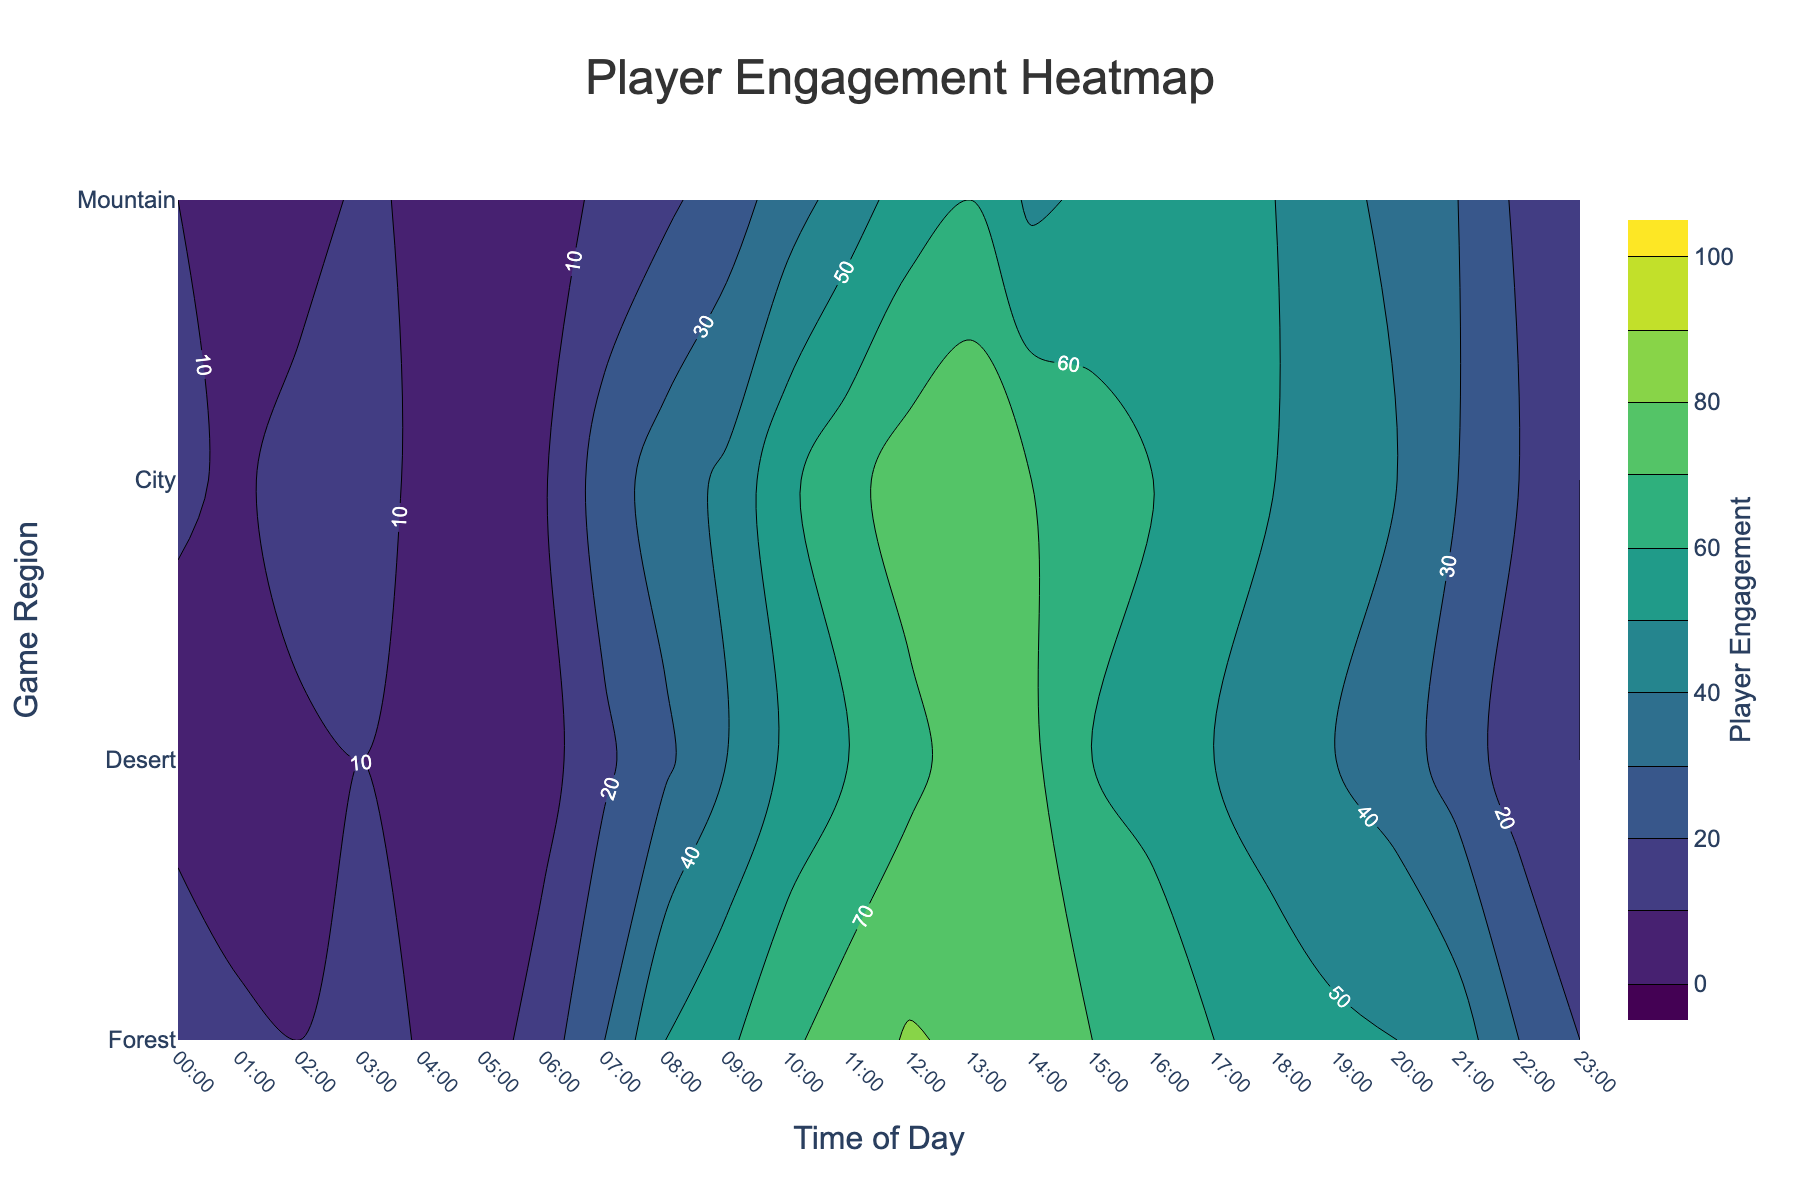What is the title of the figure? The title of the figure is displayed at the top and centered. It provides a brief description of the main theme of the plot. In this case, it reads "Player Engagement Heatmap".
Answer: Player Engagement Heatmap What do the colors in the plot represent? The colors in the contour plot indicate the levels of player engagement. A colorscale from dark to bright colors represents lower to higher engagement levels, respectively.
Answer: Levels of player engagement Which game region shows the highest player engagement, and at what time does it occur? By looking at the brightest areas in the contour plot, we can determine that the "City" region shows the highest engagement. The peak occurs around "12:00".
Answer: City at 12:00 At what time does the "Forest" region have its lowest player engagement? Observing the darkest areas in the "Forest" row, the lowest engagement level occurs at "05:00".
Answer: 05:00 How does player engagement in the "Desert" region change from 09:00 to 12:00? By tracking the contour lines for "Desert" between 09:00 and 12:00, we see that engagement steadily increases from lower to higher contour levels.
Answer: It increases What is the range of player engagement values displayed in the plot? The contour plot color bar shows the minimum and maximum values of player engagement. The range is from 0 to 100.
Answer: 0 to 100 Compare the player engagement between "Mountain" and "Desert" regions at 18:00. Which is higher? Examining the corresponding positions in the contour plot, the "Mountain" region has a higher engagement level than the "Desert" region at 18:00.
Answer: Mountain Which region shows the least variability in player engagement throughout the day? By observing the contour lines, the "Mountain" region shows the least variability with more evenly spaced contours, indicating more consistent engagement levels.
Answer: Mountain What are the player engagement values for "City" at 08:00 and "Mountain" at 08:00? Checking the color and contour positions for "City" at 08:00, the value is approximately 50. For "Mountain" at 08:00, it's around 18.
Answer: City: 50, Mountain: 18 What is the average player engagement in the "Forest" region from 00:00 to 23:00? To find the average, sum up all the engagement values for "Forest" (12 + 8 + 15 + 20 + 5 + 3 + 9 + 25 + 35 + 42 + 58 + 67 + 75 + 80 + 70 + 65 + 60 + 55 + 50 + 45 + 40 + 30 + 20 + 10) which equals 928. There are 24 values, so 928/24 = 38.67.
Answer: 38.67 